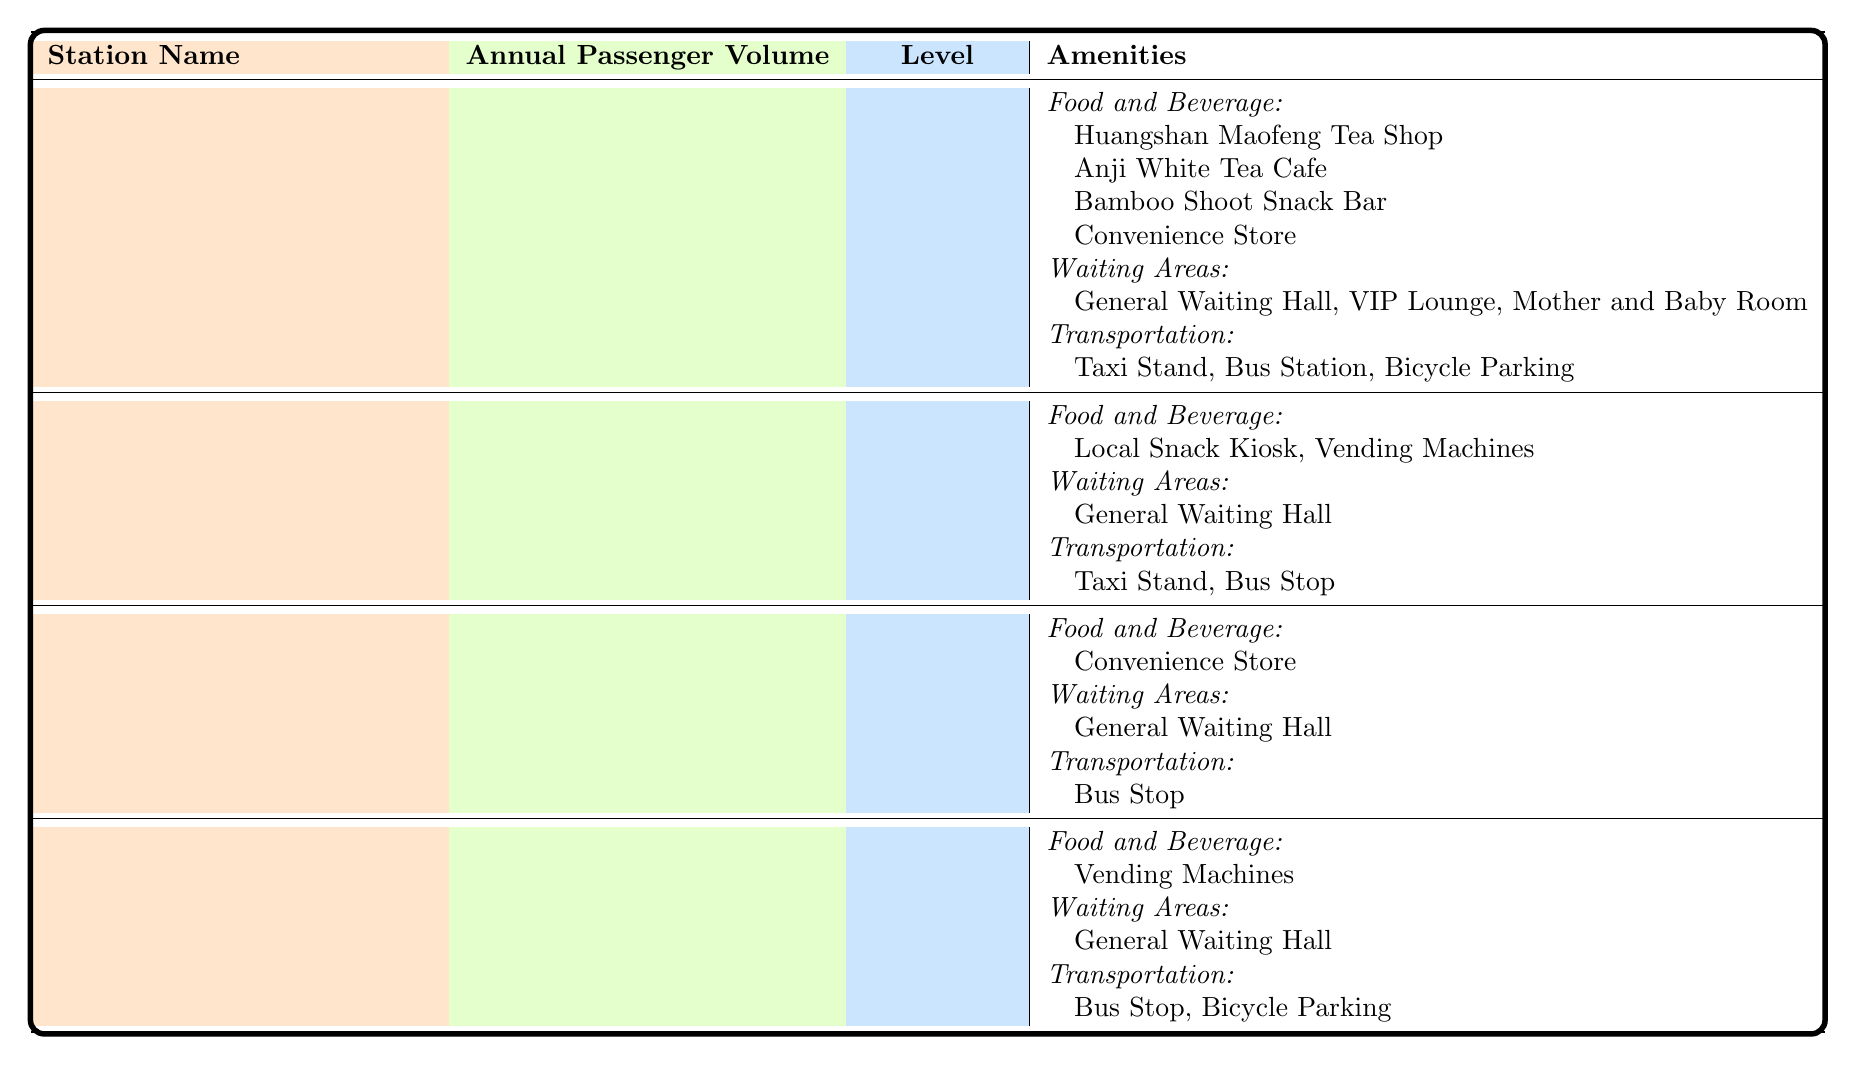What is the annual passenger volume of Anji South Railway Station? The table lists Anji South Railway Station with an annual passenger volume of 2,450,000.
Answer: 2,450,000 Which station has the second-highest annual passenger volume? The station with the second-highest annual passenger volume is Dipu Railway Station, with a volume of 980,000.
Answer: Dipu Railway Station Does Lingfeng Railway Station have any food and beverage options available? According to the table, Lingfeng Railway Station has vending machines as a food and beverage option.
Answer: Yes Which two stations are classified as third-class? The table shows that both Tianhuangping Railway Station and Lingfeng Railway Station are classified as third-class.
Answer: Tianhuangping Railway Station and Lingfeng Railway Station What is the total annual passenger volume of all the stations combined? Adding the annual passenger volumes: 2,450,000 (Anji South) + 980,000 (Dipu) + 620,000 (Tianhuangping) + 450,000 (Lingfeng) equals 4,500,000.
Answer: 4,500,000 What types of transportation options are available at Anji South Railway Station? The table indicates that Anji South Railway Station offers a Taxi Stand, Bus Station, and Bicycle Parking for transportation options.
Answer: Taxi Stand, Bus Station, Bicycle Parking Is there a VIP Lounge available at Dipu Railway Station? Checking the amenities for Dipu Railway Station, it does not list a VIP Lounge, only a General Waiting Hall.
Answer: No Which station provides the most diverse food and beverage options? Anji South Railway Station has the most diverse options, including four different places, compared to the others which have fewer options.
Answer: Anji South Railway Station What amenities does Tianhuangping Railway Station have for waiting areas? The only waiting area option provided for Tianhuangping Railway Station is a General Waiting Hall.
Answer: General Waiting Hall How many food and beverage options are available at Dipu Railway Station? The table lists two food and beverage options available at Dipu Railway Station: Local Snack Kiosk and Vending Machines.
Answer: 2 